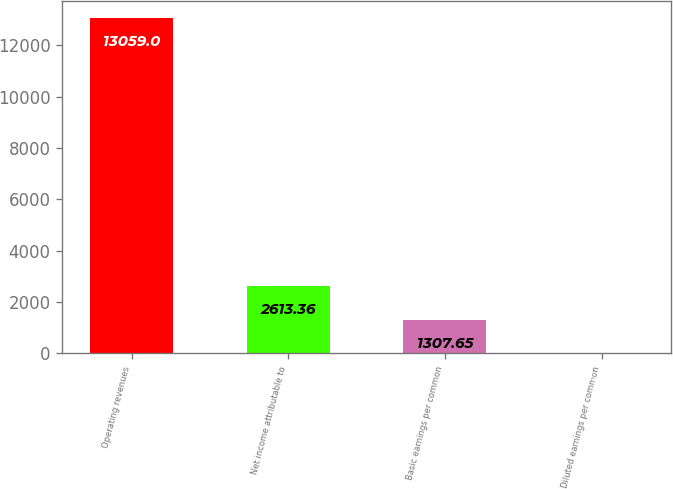<chart> <loc_0><loc_0><loc_500><loc_500><bar_chart><fcel>Operating revenues<fcel>Net income attributable to<fcel>Basic earnings per common<fcel>Diluted earnings per common<nl><fcel>13059<fcel>2613.36<fcel>1307.65<fcel>1.94<nl></chart> 